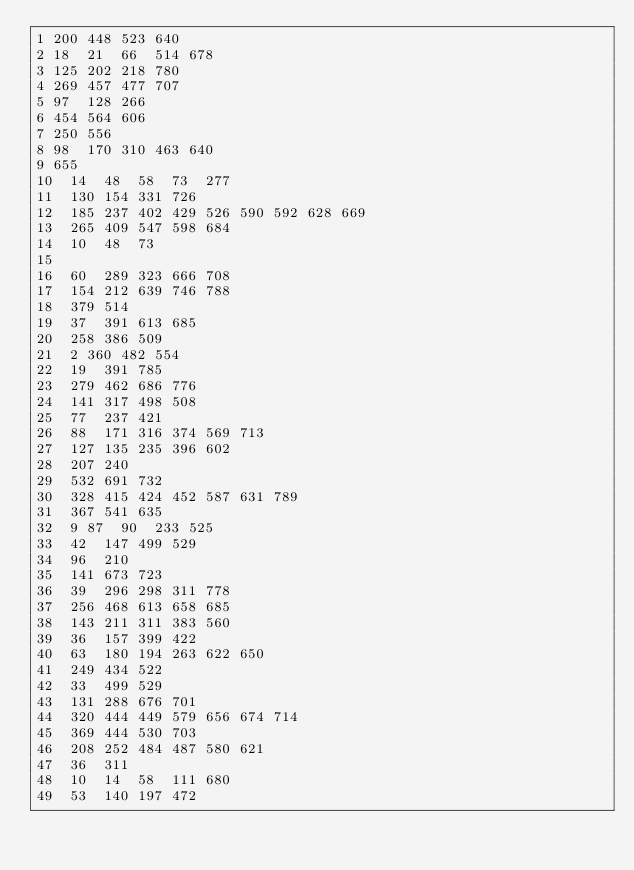<code> <loc_0><loc_0><loc_500><loc_500><_Perl_>1	200	448	523	640
2	18	21	66	514	678
3	125	202	218	780
4	269	457	477	707
5	97	128	266
6	454	564	606
7	250	556
8	98	170	310	463	640
9	655
10	14	48	58	73	277
11	130	154	331	726
12	185	237	402	429	526	590	592	628	669
13	265	409	547	598	684
14	10	48	73
15
16	60	289	323	666	708
17	154	212	639	746	788
18	379	514
19	37	391	613	685
20	258	386	509
21	2	360	482	554
22	19	391	785
23	279	462	686	776
24	141	317	498	508
25	77	237	421
26	88	171	316	374	569	713
27	127	135	235	396	602
28	207	240
29	532	691	732
30	328	415	424	452	587	631	789
31	367	541	635
32	9	87	90	233	525
33	42	147	499	529
34	96	210
35	141	673	723
36	39	296	298	311	778
37	256	468	613	658	685
38	143	211	311	383	560
39	36	157	399	422
40	63	180	194	263	622	650
41	249	434	522
42	33	499	529
43	131	288	676	701
44	320	444	449	579	656	674	714
45	369	444	530	703
46	208	252	484	487	580	621
47	36	311
48	10	14	58	111	680
49	53	140	197	472</code> 